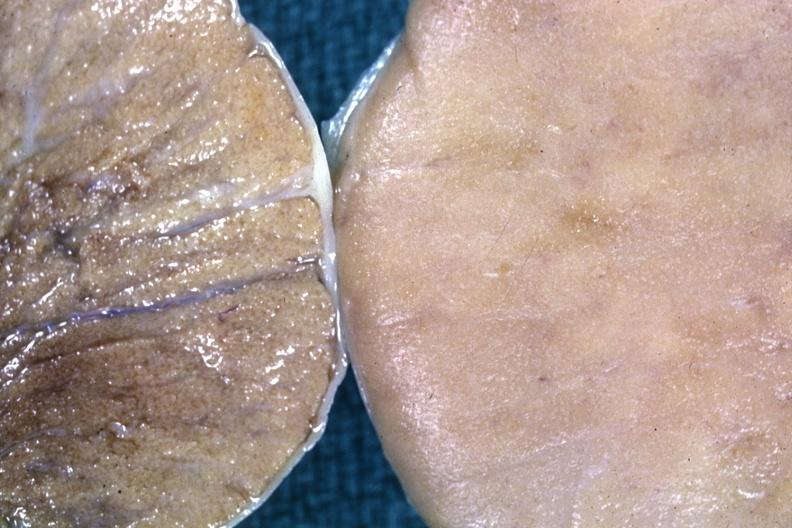s malignant lymphoma present?
Answer the question using a single word or phrase. Yes 